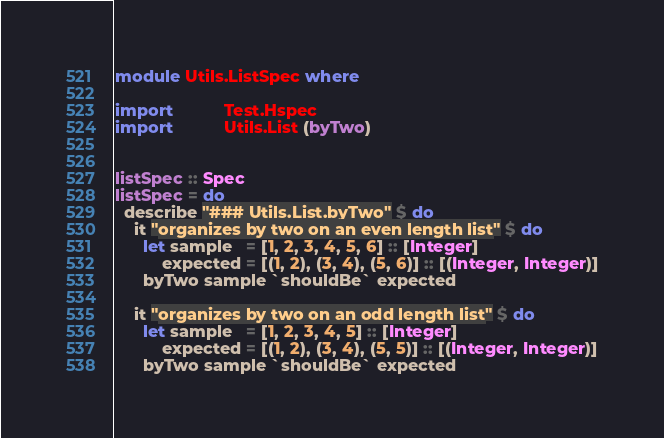Convert code to text. <code><loc_0><loc_0><loc_500><loc_500><_Haskell_>module Utils.ListSpec where

import           Test.Hspec
import           Utils.List (byTwo)


listSpec :: Spec
listSpec = do
  describe "### Utils.List.byTwo" $ do
    it "organizes by two on an even length list" $ do
      let sample   = [1, 2, 3, 4, 5, 6] :: [Integer]
          expected = [(1, 2), (3, 4), (5, 6)] :: [(Integer, Integer)]
      byTwo sample `shouldBe` expected

    it "organizes by two on an odd length list" $ do
      let sample   = [1, 2, 3, 4, 5] :: [Integer]
          expected = [(1, 2), (3, 4), (5, 5)] :: [(Integer, Integer)]
      byTwo sample `shouldBe` expected
</code> 